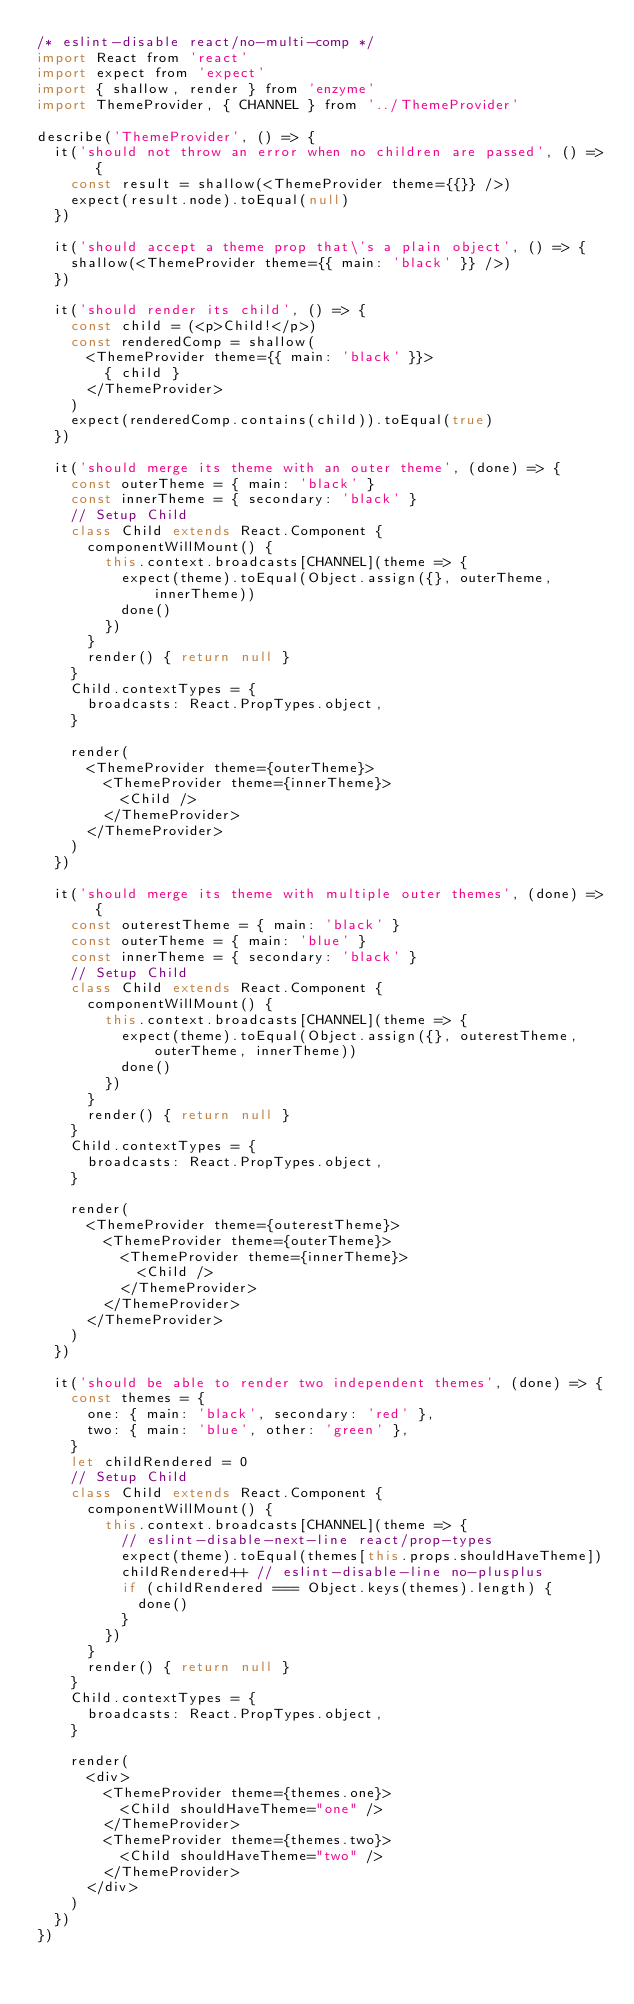<code> <loc_0><loc_0><loc_500><loc_500><_JavaScript_>/* eslint-disable react/no-multi-comp */
import React from 'react'
import expect from 'expect'
import { shallow, render } from 'enzyme'
import ThemeProvider, { CHANNEL } from '../ThemeProvider'

describe('ThemeProvider', () => {
  it('should not throw an error when no children are passed', () => {
    const result = shallow(<ThemeProvider theme={{}} />)
    expect(result.node).toEqual(null)
  })

  it('should accept a theme prop that\'s a plain object', () => {
    shallow(<ThemeProvider theme={{ main: 'black' }} />)
  })

  it('should render its child', () => {
    const child = (<p>Child!</p>)
    const renderedComp = shallow(
      <ThemeProvider theme={{ main: 'black' }}>
        { child }
      </ThemeProvider>
    )
    expect(renderedComp.contains(child)).toEqual(true)
  })

  it('should merge its theme with an outer theme', (done) => {
    const outerTheme = { main: 'black' }
    const innerTheme = { secondary: 'black' }
    // Setup Child
    class Child extends React.Component {
      componentWillMount() {
        this.context.broadcasts[CHANNEL](theme => {
          expect(theme).toEqual(Object.assign({}, outerTheme, innerTheme))
          done()
        })
      }
      render() { return null }
    }
    Child.contextTypes = {
      broadcasts: React.PropTypes.object,
    }

    render(
      <ThemeProvider theme={outerTheme}>
        <ThemeProvider theme={innerTheme}>
          <Child />
        </ThemeProvider>
      </ThemeProvider>
    )
  })

  it('should merge its theme with multiple outer themes', (done) => {
    const outerestTheme = { main: 'black' }
    const outerTheme = { main: 'blue' }
    const innerTheme = { secondary: 'black' }
    // Setup Child
    class Child extends React.Component {
      componentWillMount() {
        this.context.broadcasts[CHANNEL](theme => {
          expect(theme).toEqual(Object.assign({}, outerestTheme, outerTheme, innerTheme))
          done()
        })
      }
      render() { return null }
    }
    Child.contextTypes = {
      broadcasts: React.PropTypes.object,
    }

    render(
      <ThemeProvider theme={outerestTheme}>
        <ThemeProvider theme={outerTheme}>
          <ThemeProvider theme={innerTheme}>
            <Child />
          </ThemeProvider>
        </ThemeProvider>
      </ThemeProvider>
    )
  })

  it('should be able to render two independent themes', (done) => {
    const themes = {
      one: { main: 'black', secondary: 'red' },
      two: { main: 'blue', other: 'green' },
    }
    let childRendered = 0
    // Setup Child
    class Child extends React.Component {
      componentWillMount() {
        this.context.broadcasts[CHANNEL](theme => {
          // eslint-disable-next-line react/prop-types
          expect(theme).toEqual(themes[this.props.shouldHaveTheme])
          childRendered++ // eslint-disable-line no-plusplus
          if (childRendered === Object.keys(themes).length) {
            done()
          }
        })
      }
      render() { return null }
    }
    Child.contextTypes = {
      broadcasts: React.PropTypes.object,
    }

    render(
      <div>
        <ThemeProvider theme={themes.one}>
          <Child shouldHaveTheme="one" />
        </ThemeProvider>
        <ThemeProvider theme={themes.two}>
          <Child shouldHaveTheme="two" />
        </ThemeProvider>
      </div>
    )
  })
})
</code> 